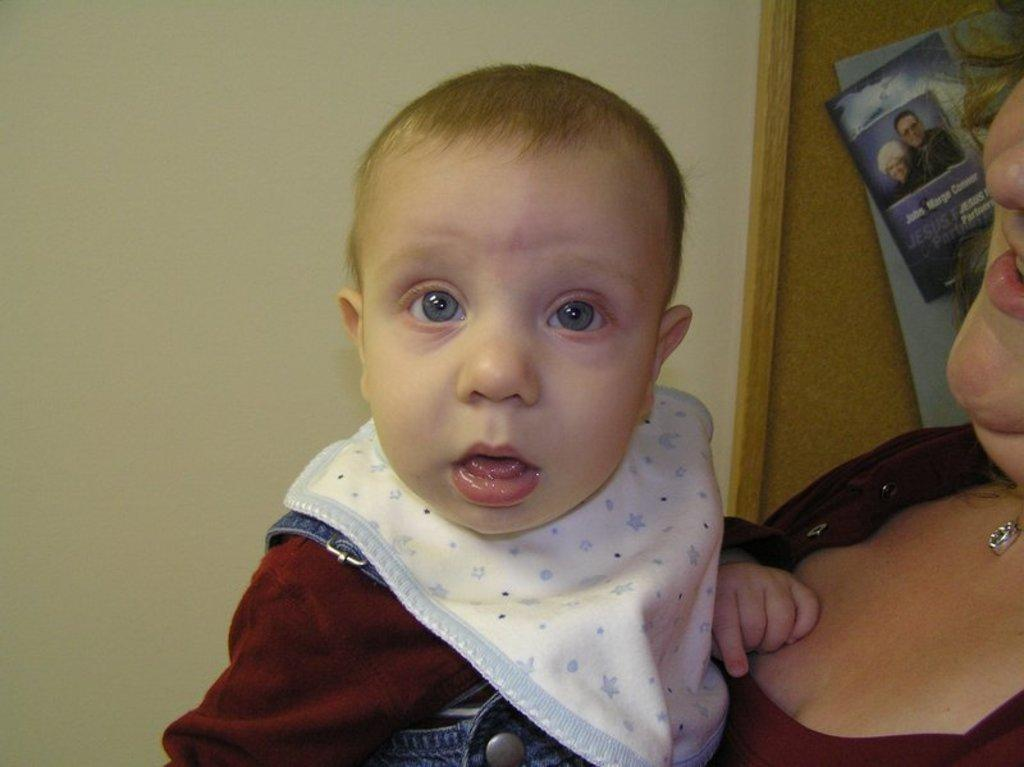What is the main subject of the image? There is a baby in the image. Is there anyone else in the image besides the baby? Yes, there is a person in the image. What is the baby doing in the image? The baby is watching something. What can be seen in the background of the image? There is a wall, wooden objects, and posters in the background of the image. What type of laborer is depicted in the image? There is no laborer present in the image. What is the baby's rank in the army in the image? There is no army or military context in the image; it features a baby and a person in a setting with a wall, wooden objects, and posters in the background. 